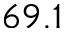<formula> <loc_0><loc_0><loc_500><loc_500>6 9 . 1</formula> 